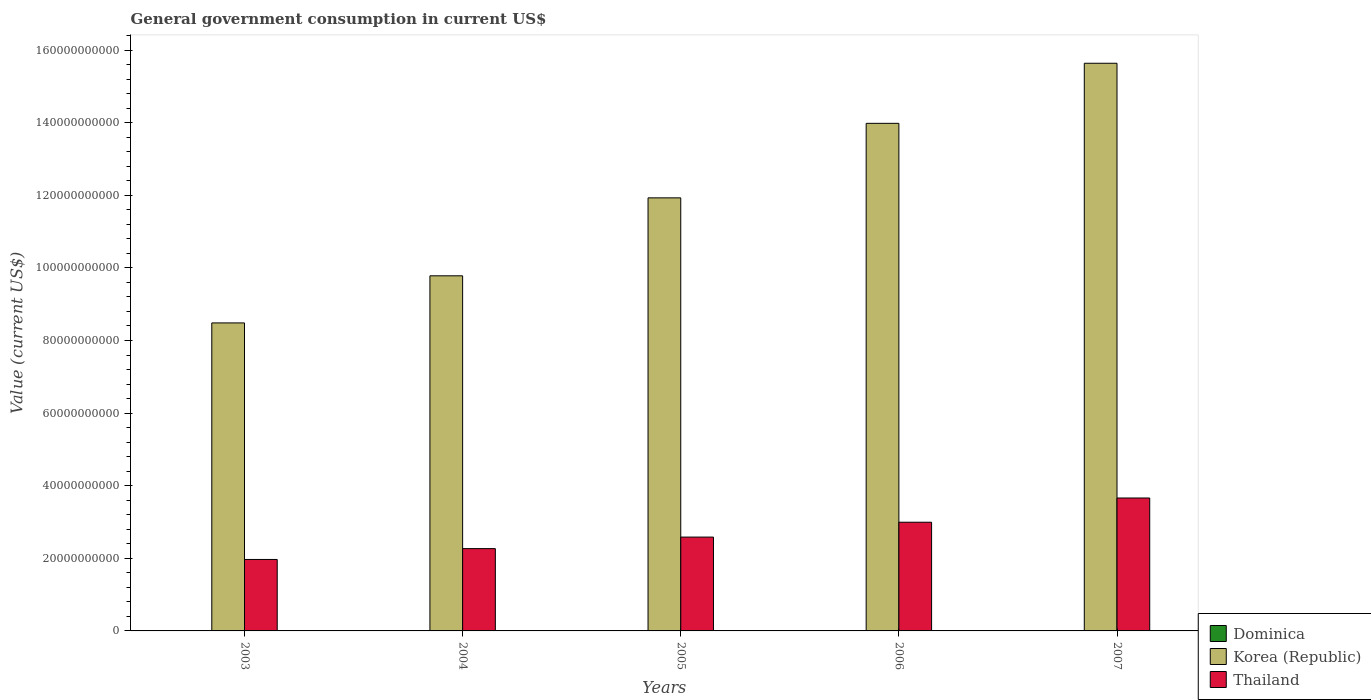How many different coloured bars are there?
Your answer should be very brief. 3. How many bars are there on the 2nd tick from the left?
Your answer should be very brief. 3. What is the government conusmption in Korea (Republic) in 2004?
Make the answer very short. 9.78e+1. Across all years, what is the maximum government conusmption in Thailand?
Provide a short and direct response. 3.66e+1. Across all years, what is the minimum government conusmption in Korea (Republic)?
Make the answer very short. 8.48e+1. In which year was the government conusmption in Dominica minimum?
Your answer should be compact. 2003. What is the total government conusmption in Korea (Republic) in the graph?
Your answer should be very brief. 5.98e+11. What is the difference between the government conusmption in Thailand in 2005 and that in 2007?
Keep it short and to the point. -1.08e+1. What is the difference between the government conusmption in Dominica in 2005 and the government conusmption in Thailand in 2006?
Provide a short and direct response. -2.99e+1. What is the average government conusmption in Korea (Republic) per year?
Provide a short and direct response. 1.20e+11. In the year 2004, what is the difference between the government conusmption in Thailand and government conusmption in Dominica?
Your response must be concise. 2.26e+1. What is the ratio of the government conusmption in Thailand in 2006 to that in 2007?
Keep it short and to the point. 0.82. What is the difference between the highest and the second highest government conusmption in Thailand?
Offer a terse response. 6.67e+09. What is the difference between the highest and the lowest government conusmption in Dominica?
Provide a succinct answer. 1.72e+07. In how many years, is the government conusmption in Thailand greater than the average government conusmption in Thailand taken over all years?
Provide a succinct answer. 2. What does the 3rd bar from the left in 2007 represents?
Provide a short and direct response. Thailand. What does the 2nd bar from the right in 2004 represents?
Make the answer very short. Korea (Republic). How many bars are there?
Provide a short and direct response. 15. How many years are there in the graph?
Offer a very short reply. 5. Are the values on the major ticks of Y-axis written in scientific E-notation?
Your answer should be compact. No. Does the graph contain any zero values?
Your answer should be compact. No. Where does the legend appear in the graph?
Keep it short and to the point. Bottom right. How many legend labels are there?
Your answer should be compact. 3. What is the title of the graph?
Offer a terse response. General government consumption in current US$. What is the label or title of the Y-axis?
Provide a succinct answer. Value (current US$). What is the Value (current US$) in Dominica in 2003?
Your answer should be compact. 5.13e+07. What is the Value (current US$) in Korea (Republic) in 2003?
Provide a succinct answer. 8.48e+1. What is the Value (current US$) of Thailand in 2003?
Your answer should be very brief. 1.97e+1. What is the Value (current US$) in Dominica in 2004?
Offer a terse response. 5.27e+07. What is the Value (current US$) of Korea (Republic) in 2004?
Offer a very short reply. 9.78e+1. What is the Value (current US$) in Thailand in 2004?
Your response must be concise. 2.27e+1. What is the Value (current US$) of Dominica in 2005?
Provide a succinct answer. 5.74e+07. What is the Value (current US$) of Korea (Republic) in 2005?
Provide a succinct answer. 1.19e+11. What is the Value (current US$) of Thailand in 2005?
Offer a terse response. 2.58e+1. What is the Value (current US$) in Dominica in 2006?
Your answer should be compact. 6.11e+07. What is the Value (current US$) of Korea (Republic) in 2006?
Your answer should be very brief. 1.40e+11. What is the Value (current US$) of Thailand in 2006?
Give a very brief answer. 2.99e+1. What is the Value (current US$) of Dominica in 2007?
Offer a very short reply. 6.85e+07. What is the Value (current US$) in Korea (Republic) in 2007?
Provide a succinct answer. 1.56e+11. What is the Value (current US$) of Thailand in 2007?
Offer a very short reply. 3.66e+1. Across all years, what is the maximum Value (current US$) in Dominica?
Give a very brief answer. 6.85e+07. Across all years, what is the maximum Value (current US$) of Korea (Republic)?
Keep it short and to the point. 1.56e+11. Across all years, what is the maximum Value (current US$) of Thailand?
Your answer should be compact. 3.66e+1. Across all years, what is the minimum Value (current US$) of Dominica?
Provide a succinct answer. 5.13e+07. Across all years, what is the minimum Value (current US$) of Korea (Republic)?
Ensure brevity in your answer.  8.48e+1. Across all years, what is the minimum Value (current US$) of Thailand?
Give a very brief answer. 1.97e+1. What is the total Value (current US$) of Dominica in the graph?
Offer a very short reply. 2.91e+08. What is the total Value (current US$) of Korea (Republic) in the graph?
Provide a short and direct response. 5.98e+11. What is the total Value (current US$) of Thailand in the graph?
Your answer should be very brief. 1.35e+11. What is the difference between the Value (current US$) of Dominica in 2003 and that in 2004?
Offer a terse response. -1.39e+06. What is the difference between the Value (current US$) in Korea (Republic) in 2003 and that in 2004?
Make the answer very short. -1.30e+1. What is the difference between the Value (current US$) in Thailand in 2003 and that in 2004?
Provide a succinct answer. -2.99e+09. What is the difference between the Value (current US$) of Dominica in 2003 and that in 2005?
Your answer should be compact. -6.07e+06. What is the difference between the Value (current US$) of Korea (Republic) in 2003 and that in 2005?
Make the answer very short. -3.45e+1. What is the difference between the Value (current US$) in Thailand in 2003 and that in 2005?
Your response must be concise. -6.17e+09. What is the difference between the Value (current US$) in Dominica in 2003 and that in 2006?
Provide a succinct answer. -9.77e+06. What is the difference between the Value (current US$) of Korea (Republic) in 2003 and that in 2006?
Offer a very short reply. -5.50e+1. What is the difference between the Value (current US$) in Thailand in 2003 and that in 2006?
Give a very brief answer. -1.03e+1. What is the difference between the Value (current US$) of Dominica in 2003 and that in 2007?
Provide a succinct answer. -1.72e+07. What is the difference between the Value (current US$) in Korea (Republic) in 2003 and that in 2007?
Keep it short and to the point. -7.15e+1. What is the difference between the Value (current US$) in Thailand in 2003 and that in 2007?
Make the answer very short. -1.69e+1. What is the difference between the Value (current US$) of Dominica in 2004 and that in 2005?
Provide a succinct answer. -4.67e+06. What is the difference between the Value (current US$) in Korea (Republic) in 2004 and that in 2005?
Give a very brief answer. -2.15e+1. What is the difference between the Value (current US$) of Thailand in 2004 and that in 2005?
Ensure brevity in your answer.  -3.18e+09. What is the difference between the Value (current US$) of Dominica in 2004 and that in 2006?
Offer a very short reply. -8.38e+06. What is the difference between the Value (current US$) of Korea (Republic) in 2004 and that in 2006?
Your answer should be very brief. -4.20e+1. What is the difference between the Value (current US$) in Thailand in 2004 and that in 2006?
Keep it short and to the point. -7.27e+09. What is the difference between the Value (current US$) in Dominica in 2004 and that in 2007?
Your answer should be very brief. -1.58e+07. What is the difference between the Value (current US$) of Korea (Republic) in 2004 and that in 2007?
Offer a terse response. -5.86e+1. What is the difference between the Value (current US$) in Thailand in 2004 and that in 2007?
Ensure brevity in your answer.  -1.39e+1. What is the difference between the Value (current US$) in Dominica in 2005 and that in 2006?
Offer a terse response. -3.70e+06. What is the difference between the Value (current US$) of Korea (Republic) in 2005 and that in 2006?
Ensure brevity in your answer.  -2.05e+1. What is the difference between the Value (current US$) in Thailand in 2005 and that in 2006?
Make the answer very short. -4.09e+09. What is the difference between the Value (current US$) in Dominica in 2005 and that in 2007?
Ensure brevity in your answer.  -1.11e+07. What is the difference between the Value (current US$) of Korea (Republic) in 2005 and that in 2007?
Your answer should be very brief. -3.71e+1. What is the difference between the Value (current US$) in Thailand in 2005 and that in 2007?
Your answer should be very brief. -1.08e+1. What is the difference between the Value (current US$) of Dominica in 2006 and that in 2007?
Your answer should be compact. -7.41e+06. What is the difference between the Value (current US$) in Korea (Republic) in 2006 and that in 2007?
Your answer should be very brief. -1.66e+1. What is the difference between the Value (current US$) of Thailand in 2006 and that in 2007?
Provide a short and direct response. -6.67e+09. What is the difference between the Value (current US$) in Dominica in 2003 and the Value (current US$) in Korea (Republic) in 2004?
Your answer should be compact. -9.78e+1. What is the difference between the Value (current US$) in Dominica in 2003 and the Value (current US$) in Thailand in 2004?
Your answer should be very brief. -2.26e+1. What is the difference between the Value (current US$) of Korea (Republic) in 2003 and the Value (current US$) of Thailand in 2004?
Your response must be concise. 6.22e+1. What is the difference between the Value (current US$) of Dominica in 2003 and the Value (current US$) of Korea (Republic) in 2005?
Ensure brevity in your answer.  -1.19e+11. What is the difference between the Value (current US$) of Dominica in 2003 and the Value (current US$) of Thailand in 2005?
Provide a short and direct response. -2.58e+1. What is the difference between the Value (current US$) of Korea (Republic) in 2003 and the Value (current US$) of Thailand in 2005?
Keep it short and to the point. 5.90e+1. What is the difference between the Value (current US$) of Dominica in 2003 and the Value (current US$) of Korea (Republic) in 2006?
Ensure brevity in your answer.  -1.40e+11. What is the difference between the Value (current US$) in Dominica in 2003 and the Value (current US$) in Thailand in 2006?
Offer a terse response. -2.99e+1. What is the difference between the Value (current US$) of Korea (Republic) in 2003 and the Value (current US$) of Thailand in 2006?
Ensure brevity in your answer.  5.49e+1. What is the difference between the Value (current US$) of Dominica in 2003 and the Value (current US$) of Korea (Republic) in 2007?
Ensure brevity in your answer.  -1.56e+11. What is the difference between the Value (current US$) of Dominica in 2003 and the Value (current US$) of Thailand in 2007?
Offer a terse response. -3.66e+1. What is the difference between the Value (current US$) in Korea (Republic) in 2003 and the Value (current US$) in Thailand in 2007?
Make the answer very short. 4.82e+1. What is the difference between the Value (current US$) in Dominica in 2004 and the Value (current US$) in Korea (Republic) in 2005?
Ensure brevity in your answer.  -1.19e+11. What is the difference between the Value (current US$) in Dominica in 2004 and the Value (current US$) in Thailand in 2005?
Your answer should be compact. -2.58e+1. What is the difference between the Value (current US$) in Korea (Republic) in 2004 and the Value (current US$) in Thailand in 2005?
Make the answer very short. 7.20e+1. What is the difference between the Value (current US$) in Dominica in 2004 and the Value (current US$) in Korea (Republic) in 2006?
Make the answer very short. -1.40e+11. What is the difference between the Value (current US$) in Dominica in 2004 and the Value (current US$) in Thailand in 2006?
Your answer should be very brief. -2.99e+1. What is the difference between the Value (current US$) in Korea (Republic) in 2004 and the Value (current US$) in Thailand in 2006?
Make the answer very short. 6.79e+1. What is the difference between the Value (current US$) in Dominica in 2004 and the Value (current US$) in Korea (Republic) in 2007?
Your answer should be very brief. -1.56e+11. What is the difference between the Value (current US$) of Dominica in 2004 and the Value (current US$) of Thailand in 2007?
Offer a terse response. -3.66e+1. What is the difference between the Value (current US$) of Korea (Republic) in 2004 and the Value (current US$) of Thailand in 2007?
Your answer should be compact. 6.12e+1. What is the difference between the Value (current US$) of Dominica in 2005 and the Value (current US$) of Korea (Republic) in 2006?
Your answer should be very brief. -1.40e+11. What is the difference between the Value (current US$) in Dominica in 2005 and the Value (current US$) in Thailand in 2006?
Keep it short and to the point. -2.99e+1. What is the difference between the Value (current US$) in Korea (Republic) in 2005 and the Value (current US$) in Thailand in 2006?
Offer a terse response. 8.94e+1. What is the difference between the Value (current US$) in Dominica in 2005 and the Value (current US$) in Korea (Republic) in 2007?
Your answer should be very brief. -1.56e+11. What is the difference between the Value (current US$) of Dominica in 2005 and the Value (current US$) of Thailand in 2007?
Keep it short and to the point. -3.66e+1. What is the difference between the Value (current US$) of Korea (Republic) in 2005 and the Value (current US$) of Thailand in 2007?
Make the answer very short. 8.27e+1. What is the difference between the Value (current US$) of Dominica in 2006 and the Value (current US$) of Korea (Republic) in 2007?
Provide a short and direct response. -1.56e+11. What is the difference between the Value (current US$) in Dominica in 2006 and the Value (current US$) in Thailand in 2007?
Offer a very short reply. -3.66e+1. What is the difference between the Value (current US$) of Korea (Republic) in 2006 and the Value (current US$) of Thailand in 2007?
Give a very brief answer. 1.03e+11. What is the average Value (current US$) in Dominica per year?
Provide a short and direct response. 5.82e+07. What is the average Value (current US$) in Korea (Republic) per year?
Give a very brief answer. 1.20e+11. What is the average Value (current US$) in Thailand per year?
Offer a very short reply. 2.70e+1. In the year 2003, what is the difference between the Value (current US$) in Dominica and Value (current US$) in Korea (Republic)?
Your answer should be compact. -8.48e+1. In the year 2003, what is the difference between the Value (current US$) of Dominica and Value (current US$) of Thailand?
Ensure brevity in your answer.  -1.96e+1. In the year 2003, what is the difference between the Value (current US$) in Korea (Republic) and Value (current US$) in Thailand?
Ensure brevity in your answer.  6.52e+1. In the year 2004, what is the difference between the Value (current US$) in Dominica and Value (current US$) in Korea (Republic)?
Make the answer very short. -9.78e+1. In the year 2004, what is the difference between the Value (current US$) of Dominica and Value (current US$) of Thailand?
Provide a short and direct response. -2.26e+1. In the year 2004, what is the difference between the Value (current US$) in Korea (Republic) and Value (current US$) in Thailand?
Make the answer very short. 7.51e+1. In the year 2005, what is the difference between the Value (current US$) of Dominica and Value (current US$) of Korea (Republic)?
Make the answer very short. -1.19e+11. In the year 2005, what is the difference between the Value (current US$) in Dominica and Value (current US$) in Thailand?
Provide a short and direct response. -2.58e+1. In the year 2005, what is the difference between the Value (current US$) of Korea (Republic) and Value (current US$) of Thailand?
Give a very brief answer. 9.34e+1. In the year 2006, what is the difference between the Value (current US$) in Dominica and Value (current US$) in Korea (Republic)?
Offer a very short reply. -1.40e+11. In the year 2006, what is the difference between the Value (current US$) of Dominica and Value (current US$) of Thailand?
Keep it short and to the point. -2.99e+1. In the year 2006, what is the difference between the Value (current US$) of Korea (Republic) and Value (current US$) of Thailand?
Your answer should be very brief. 1.10e+11. In the year 2007, what is the difference between the Value (current US$) in Dominica and Value (current US$) in Korea (Republic)?
Give a very brief answer. -1.56e+11. In the year 2007, what is the difference between the Value (current US$) of Dominica and Value (current US$) of Thailand?
Ensure brevity in your answer.  -3.65e+1. In the year 2007, what is the difference between the Value (current US$) of Korea (Republic) and Value (current US$) of Thailand?
Provide a succinct answer. 1.20e+11. What is the ratio of the Value (current US$) in Dominica in 2003 to that in 2004?
Your response must be concise. 0.97. What is the ratio of the Value (current US$) of Korea (Republic) in 2003 to that in 2004?
Offer a very short reply. 0.87. What is the ratio of the Value (current US$) of Thailand in 2003 to that in 2004?
Your answer should be compact. 0.87. What is the ratio of the Value (current US$) of Dominica in 2003 to that in 2005?
Give a very brief answer. 0.89. What is the ratio of the Value (current US$) in Korea (Republic) in 2003 to that in 2005?
Your answer should be very brief. 0.71. What is the ratio of the Value (current US$) in Thailand in 2003 to that in 2005?
Give a very brief answer. 0.76. What is the ratio of the Value (current US$) of Dominica in 2003 to that in 2006?
Offer a terse response. 0.84. What is the ratio of the Value (current US$) in Korea (Republic) in 2003 to that in 2006?
Your response must be concise. 0.61. What is the ratio of the Value (current US$) in Thailand in 2003 to that in 2006?
Keep it short and to the point. 0.66. What is the ratio of the Value (current US$) of Dominica in 2003 to that in 2007?
Your answer should be compact. 0.75. What is the ratio of the Value (current US$) in Korea (Republic) in 2003 to that in 2007?
Your answer should be very brief. 0.54. What is the ratio of the Value (current US$) in Thailand in 2003 to that in 2007?
Your response must be concise. 0.54. What is the ratio of the Value (current US$) of Dominica in 2004 to that in 2005?
Keep it short and to the point. 0.92. What is the ratio of the Value (current US$) of Korea (Republic) in 2004 to that in 2005?
Make the answer very short. 0.82. What is the ratio of the Value (current US$) in Thailand in 2004 to that in 2005?
Your answer should be very brief. 0.88. What is the ratio of the Value (current US$) of Dominica in 2004 to that in 2006?
Your answer should be compact. 0.86. What is the ratio of the Value (current US$) in Korea (Republic) in 2004 to that in 2006?
Provide a short and direct response. 0.7. What is the ratio of the Value (current US$) in Thailand in 2004 to that in 2006?
Make the answer very short. 0.76. What is the ratio of the Value (current US$) in Dominica in 2004 to that in 2007?
Your answer should be compact. 0.77. What is the ratio of the Value (current US$) of Korea (Republic) in 2004 to that in 2007?
Make the answer very short. 0.63. What is the ratio of the Value (current US$) of Thailand in 2004 to that in 2007?
Your answer should be compact. 0.62. What is the ratio of the Value (current US$) of Dominica in 2005 to that in 2006?
Keep it short and to the point. 0.94. What is the ratio of the Value (current US$) of Korea (Republic) in 2005 to that in 2006?
Your answer should be compact. 0.85. What is the ratio of the Value (current US$) in Thailand in 2005 to that in 2006?
Provide a short and direct response. 0.86. What is the ratio of the Value (current US$) of Dominica in 2005 to that in 2007?
Give a very brief answer. 0.84. What is the ratio of the Value (current US$) in Korea (Republic) in 2005 to that in 2007?
Give a very brief answer. 0.76. What is the ratio of the Value (current US$) of Thailand in 2005 to that in 2007?
Ensure brevity in your answer.  0.71. What is the ratio of the Value (current US$) of Dominica in 2006 to that in 2007?
Offer a terse response. 0.89. What is the ratio of the Value (current US$) of Korea (Republic) in 2006 to that in 2007?
Your response must be concise. 0.89. What is the ratio of the Value (current US$) of Thailand in 2006 to that in 2007?
Give a very brief answer. 0.82. What is the difference between the highest and the second highest Value (current US$) of Dominica?
Provide a short and direct response. 7.41e+06. What is the difference between the highest and the second highest Value (current US$) in Korea (Republic)?
Offer a terse response. 1.66e+1. What is the difference between the highest and the second highest Value (current US$) in Thailand?
Offer a very short reply. 6.67e+09. What is the difference between the highest and the lowest Value (current US$) of Dominica?
Offer a very short reply. 1.72e+07. What is the difference between the highest and the lowest Value (current US$) of Korea (Republic)?
Keep it short and to the point. 7.15e+1. What is the difference between the highest and the lowest Value (current US$) in Thailand?
Your answer should be very brief. 1.69e+1. 